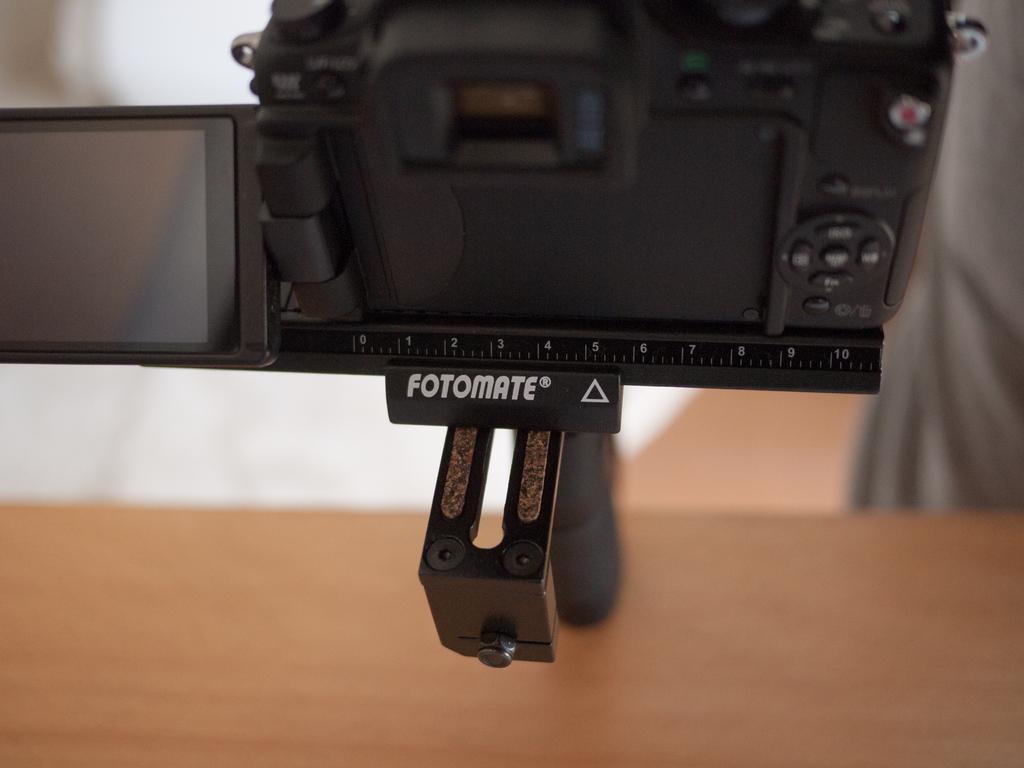Please provide a concise description of this image. This is a zoomed in picture. At the top there is a black color camera attached to the stand. In the foreground we can see a wooden object. In the background there is a wall and we can see the text on the camera. 